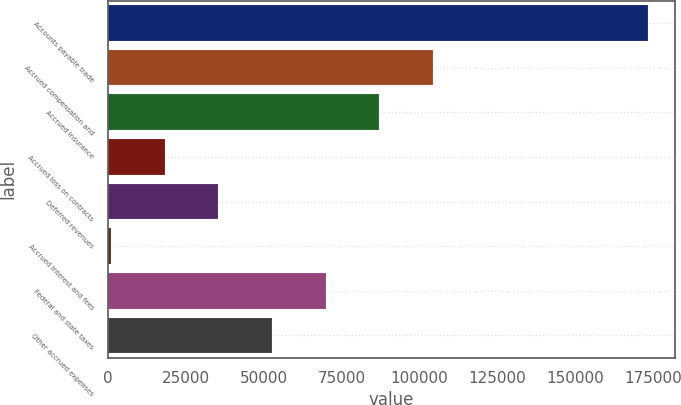<chart> <loc_0><loc_0><loc_500><loc_500><bar_chart><fcel>Accounts payable trade<fcel>Accrued compensation and<fcel>Accrued insurance<fcel>Accrued loss on contracts<fcel>Deferred revenues<fcel>Accrued interest and fees<fcel>Federal and state taxes<fcel>Other accrued expenses<nl><fcel>173301<fcel>104391<fcel>87163.5<fcel>18253.5<fcel>35481<fcel>1026<fcel>69936<fcel>52708.5<nl></chart> 